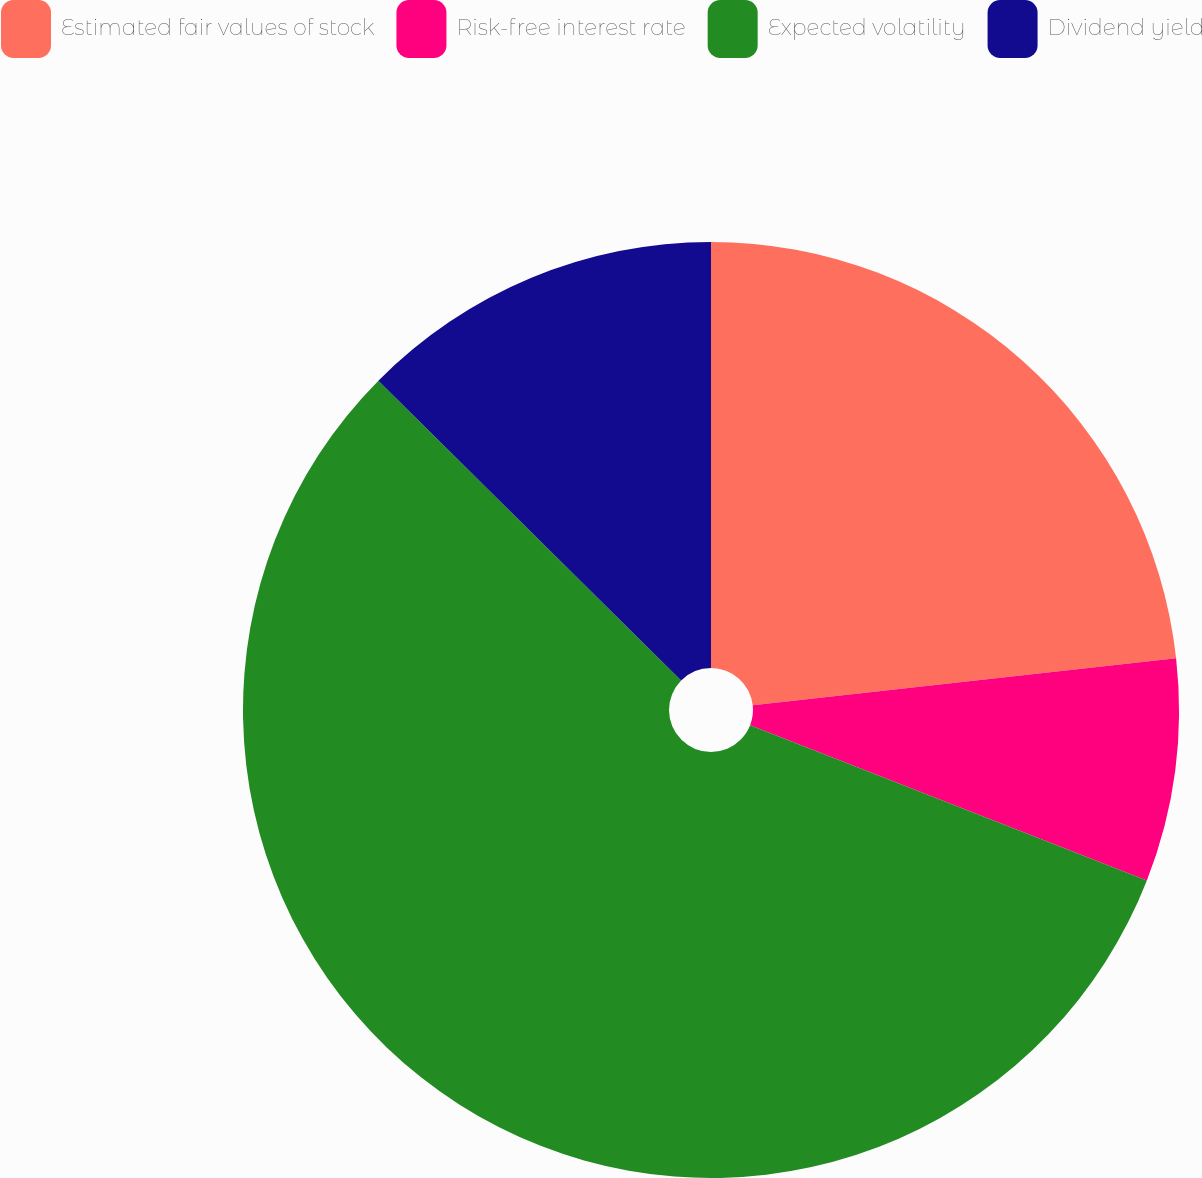Convert chart to OTSL. <chart><loc_0><loc_0><loc_500><loc_500><pie_chart><fcel>Estimated fair values of stock<fcel>Risk-free interest rate<fcel>Expected volatility<fcel>Dividend yield<nl><fcel>23.23%<fcel>7.7%<fcel>56.48%<fcel>12.58%<nl></chart> 